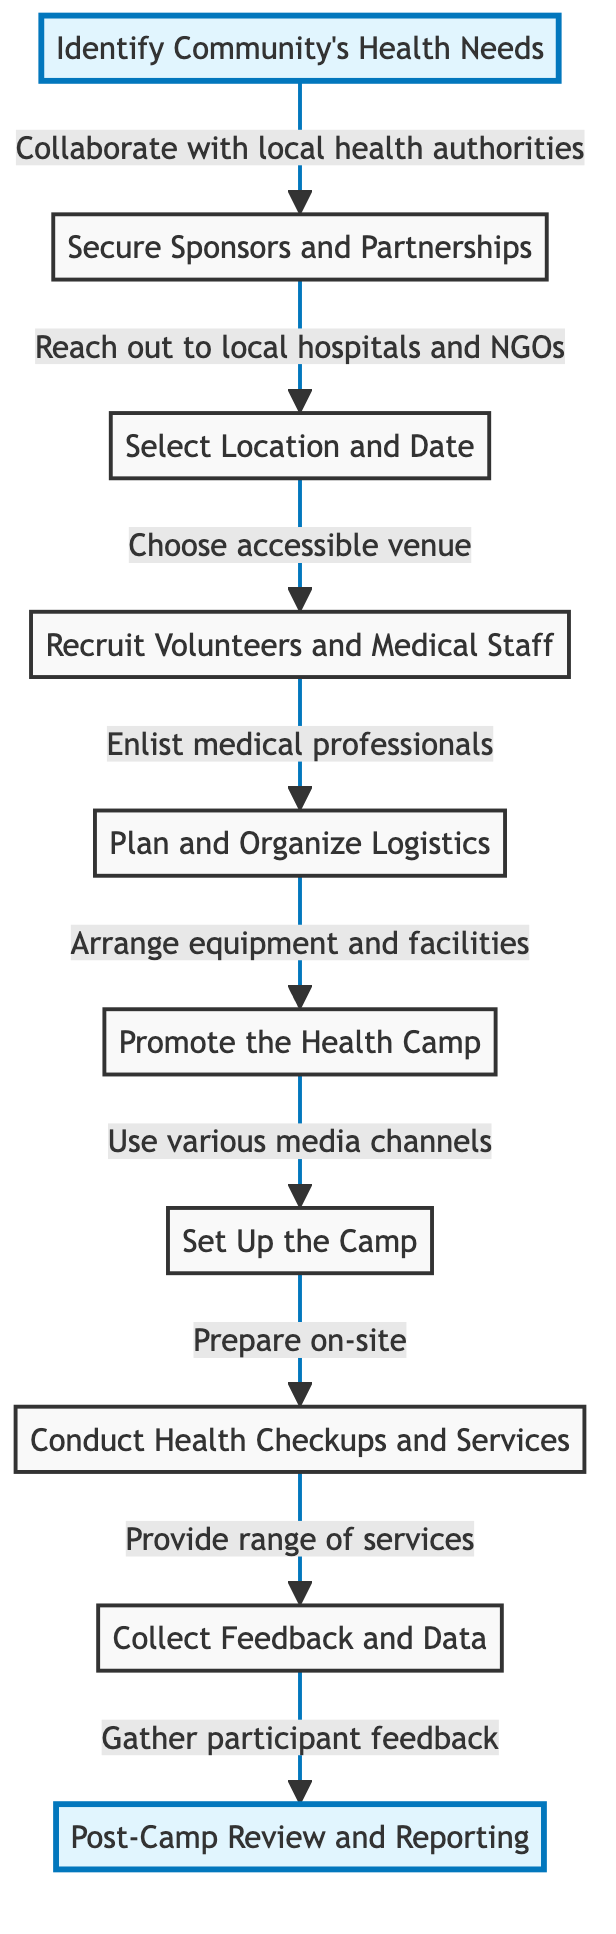What is the first step in organizing a community health camp? The diagram indicates that the first step is to "Identify the Community's Health Needs." This is visually represented as the starting point before any other actions are taken.
Answer: Identify the Community's Health Needs Which step involves choosing a venue? The diagram shows that the step involving choosing a venue is "Select a Location and Date." This follows after securing sponsors and partnerships, indicating its place in the flow of steps.
Answer: Select a Location and Date How many steps are in the process? By counting the elements in the diagram, there are a total of 10 steps from the first action to the last. This includes all actions leading to the post-camp review.
Answer: 10 What follows after planning and organizing logistics? The diagram connects "Plan and Organize Logistics" to "Promote the Health Camp," indicating this is the immediate next action to take after arranging necessary resources.
Answer: Promote the Health Camp Which step is highlighted as important in the diagram? Both "Identify the Community's Health Needs" and "Post-Camp Review and Reporting" are highlighted, signifying their importance in the overall process of organizing the health camp.
Answer: Identify the Community's Health Needs and Post-Camp Review and Reporting What type of feedback is collected after the camp? The step titled "Collect Feedback and Data" indicates that participant feedback is gathered to evaluate the camp's effectiveness and for future reference.
Answer: Participant feedback What is the purpose of recruiting volunteers and medical staff? The step "Recruit Volunteers and Medical Staff" aims to enlist qualified personnel to assist with the health camp services and ensure the necessary medical support is available.
Answer: To enlist qualified personnel Which stage involves arranging for medical equipment? The step focused on this activity is "Plan and Organize Logistics." This step specifically mentions the arrangement of medical equipment and other logistical needs.
Answer: Plan and Organize Logistics What is the last step in the flow? The final action in the sequence is "Post-Camp Review and Reporting," which concludes the process by evaluating the camp and preparing a report.
Answer: Post-Camp Review and Reporting 